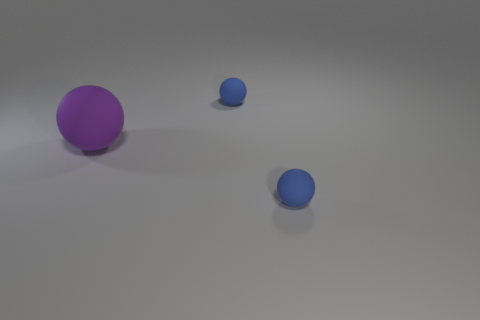Add 3 blue balls. How many objects exist? 6 Subtract all large red balls. Subtract all purple spheres. How many objects are left? 2 Add 3 blue spheres. How many blue spheres are left? 5 Add 2 small things. How many small things exist? 4 Subtract 1 blue balls. How many objects are left? 2 